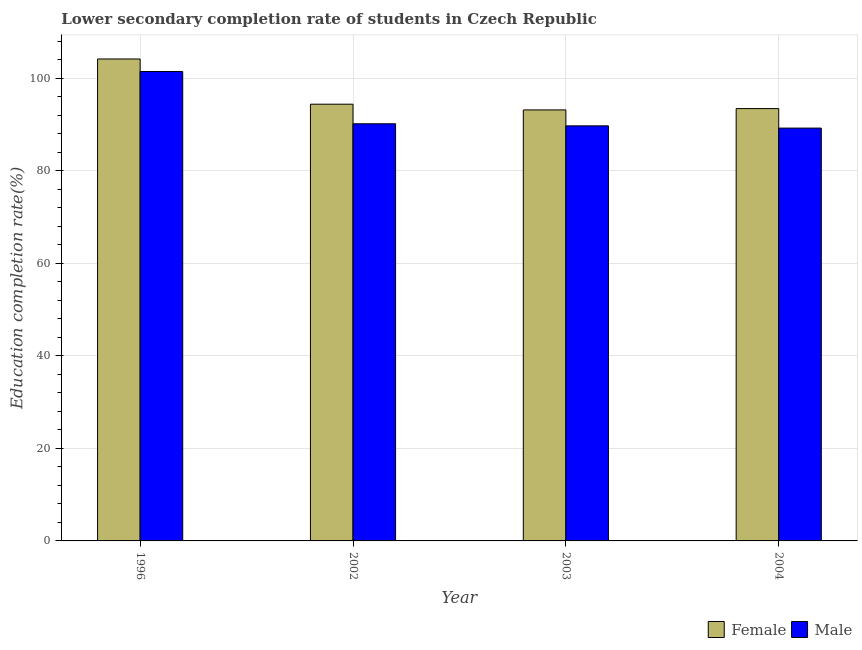How many groups of bars are there?
Offer a terse response. 4. Are the number of bars per tick equal to the number of legend labels?
Your answer should be compact. Yes. Are the number of bars on each tick of the X-axis equal?
Provide a succinct answer. Yes. How many bars are there on the 2nd tick from the left?
Provide a short and direct response. 2. How many bars are there on the 2nd tick from the right?
Your answer should be very brief. 2. What is the label of the 3rd group of bars from the left?
Keep it short and to the point. 2003. What is the education completion rate of female students in 2002?
Offer a very short reply. 94.42. Across all years, what is the maximum education completion rate of female students?
Ensure brevity in your answer.  104.2. Across all years, what is the minimum education completion rate of male students?
Your response must be concise. 89.26. What is the total education completion rate of male students in the graph?
Give a very brief answer. 370.68. What is the difference between the education completion rate of male students in 2003 and that in 2004?
Keep it short and to the point. 0.49. What is the difference between the education completion rate of female students in 2002 and the education completion rate of male students in 2003?
Make the answer very short. 1.24. What is the average education completion rate of male students per year?
Ensure brevity in your answer.  92.67. What is the ratio of the education completion rate of female students in 2002 to that in 2003?
Your response must be concise. 1.01. Is the education completion rate of female students in 1996 less than that in 2003?
Offer a terse response. No. Is the difference between the education completion rate of female students in 1996 and 2003 greater than the difference between the education completion rate of male students in 1996 and 2003?
Keep it short and to the point. No. What is the difference between the highest and the second highest education completion rate of male students?
Keep it short and to the point. 11.3. What is the difference between the highest and the lowest education completion rate of male students?
Provide a short and direct response. 12.23. Is the sum of the education completion rate of female students in 1996 and 2002 greater than the maximum education completion rate of male students across all years?
Offer a very short reply. Yes. What does the 1st bar from the right in 2003 represents?
Offer a terse response. Male. Are all the bars in the graph horizontal?
Keep it short and to the point. No. How many years are there in the graph?
Give a very brief answer. 4. What is the difference between two consecutive major ticks on the Y-axis?
Your answer should be compact. 20. Are the values on the major ticks of Y-axis written in scientific E-notation?
Give a very brief answer. No. Where does the legend appear in the graph?
Your answer should be compact. Bottom right. How many legend labels are there?
Offer a terse response. 2. How are the legend labels stacked?
Give a very brief answer. Horizontal. What is the title of the graph?
Ensure brevity in your answer.  Lower secondary completion rate of students in Czech Republic. What is the label or title of the Y-axis?
Make the answer very short. Education completion rate(%). What is the Education completion rate(%) in Female in 1996?
Make the answer very short. 104.2. What is the Education completion rate(%) of Male in 1996?
Offer a very short reply. 101.49. What is the Education completion rate(%) of Female in 2002?
Make the answer very short. 94.42. What is the Education completion rate(%) of Male in 2002?
Your answer should be very brief. 90.19. What is the Education completion rate(%) in Female in 2003?
Provide a succinct answer. 93.19. What is the Education completion rate(%) in Male in 2003?
Your answer should be very brief. 89.74. What is the Education completion rate(%) in Female in 2004?
Your response must be concise. 93.48. What is the Education completion rate(%) of Male in 2004?
Offer a terse response. 89.26. Across all years, what is the maximum Education completion rate(%) of Female?
Ensure brevity in your answer.  104.2. Across all years, what is the maximum Education completion rate(%) of Male?
Your response must be concise. 101.49. Across all years, what is the minimum Education completion rate(%) of Female?
Provide a succinct answer. 93.19. Across all years, what is the minimum Education completion rate(%) of Male?
Offer a terse response. 89.26. What is the total Education completion rate(%) of Female in the graph?
Give a very brief answer. 385.29. What is the total Education completion rate(%) in Male in the graph?
Your answer should be very brief. 370.68. What is the difference between the Education completion rate(%) of Female in 1996 and that in 2002?
Your answer should be very brief. 9.78. What is the difference between the Education completion rate(%) of Male in 1996 and that in 2002?
Ensure brevity in your answer.  11.3. What is the difference between the Education completion rate(%) of Female in 1996 and that in 2003?
Provide a succinct answer. 11.01. What is the difference between the Education completion rate(%) in Male in 1996 and that in 2003?
Give a very brief answer. 11.74. What is the difference between the Education completion rate(%) of Female in 1996 and that in 2004?
Ensure brevity in your answer.  10.73. What is the difference between the Education completion rate(%) in Male in 1996 and that in 2004?
Offer a very short reply. 12.23. What is the difference between the Education completion rate(%) in Female in 2002 and that in 2003?
Keep it short and to the point. 1.24. What is the difference between the Education completion rate(%) of Male in 2002 and that in 2003?
Provide a succinct answer. 0.45. What is the difference between the Education completion rate(%) of Female in 2002 and that in 2004?
Your answer should be compact. 0.95. What is the difference between the Education completion rate(%) in Male in 2002 and that in 2004?
Your answer should be very brief. 0.93. What is the difference between the Education completion rate(%) in Female in 2003 and that in 2004?
Your answer should be very brief. -0.29. What is the difference between the Education completion rate(%) in Male in 2003 and that in 2004?
Offer a terse response. 0.49. What is the difference between the Education completion rate(%) in Female in 1996 and the Education completion rate(%) in Male in 2002?
Keep it short and to the point. 14.01. What is the difference between the Education completion rate(%) of Female in 1996 and the Education completion rate(%) of Male in 2003?
Your answer should be compact. 14.46. What is the difference between the Education completion rate(%) of Female in 1996 and the Education completion rate(%) of Male in 2004?
Provide a succinct answer. 14.94. What is the difference between the Education completion rate(%) in Female in 2002 and the Education completion rate(%) in Male in 2003?
Provide a succinct answer. 4.68. What is the difference between the Education completion rate(%) in Female in 2002 and the Education completion rate(%) in Male in 2004?
Keep it short and to the point. 5.17. What is the difference between the Education completion rate(%) of Female in 2003 and the Education completion rate(%) of Male in 2004?
Offer a very short reply. 3.93. What is the average Education completion rate(%) in Female per year?
Provide a short and direct response. 96.32. What is the average Education completion rate(%) of Male per year?
Your answer should be compact. 92.67. In the year 1996, what is the difference between the Education completion rate(%) of Female and Education completion rate(%) of Male?
Provide a short and direct response. 2.71. In the year 2002, what is the difference between the Education completion rate(%) in Female and Education completion rate(%) in Male?
Offer a terse response. 4.23. In the year 2003, what is the difference between the Education completion rate(%) of Female and Education completion rate(%) of Male?
Make the answer very short. 3.45. In the year 2004, what is the difference between the Education completion rate(%) in Female and Education completion rate(%) in Male?
Offer a very short reply. 4.22. What is the ratio of the Education completion rate(%) in Female in 1996 to that in 2002?
Keep it short and to the point. 1.1. What is the ratio of the Education completion rate(%) of Male in 1996 to that in 2002?
Ensure brevity in your answer.  1.13. What is the ratio of the Education completion rate(%) in Female in 1996 to that in 2003?
Keep it short and to the point. 1.12. What is the ratio of the Education completion rate(%) of Male in 1996 to that in 2003?
Offer a terse response. 1.13. What is the ratio of the Education completion rate(%) of Female in 1996 to that in 2004?
Your response must be concise. 1.11. What is the ratio of the Education completion rate(%) in Male in 1996 to that in 2004?
Provide a succinct answer. 1.14. What is the ratio of the Education completion rate(%) in Female in 2002 to that in 2003?
Give a very brief answer. 1.01. What is the ratio of the Education completion rate(%) of Female in 2002 to that in 2004?
Your response must be concise. 1.01. What is the ratio of the Education completion rate(%) in Male in 2002 to that in 2004?
Ensure brevity in your answer.  1.01. What is the ratio of the Education completion rate(%) in Female in 2003 to that in 2004?
Keep it short and to the point. 1. What is the ratio of the Education completion rate(%) in Male in 2003 to that in 2004?
Provide a short and direct response. 1.01. What is the difference between the highest and the second highest Education completion rate(%) in Female?
Offer a very short reply. 9.78. What is the difference between the highest and the second highest Education completion rate(%) of Male?
Your answer should be compact. 11.3. What is the difference between the highest and the lowest Education completion rate(%) in Female?
Give a very brief answer. 11.01. What is the difference between the highest and the lowest Education completion rate(%) of Male?
Offer a very short reply. 12.23. 